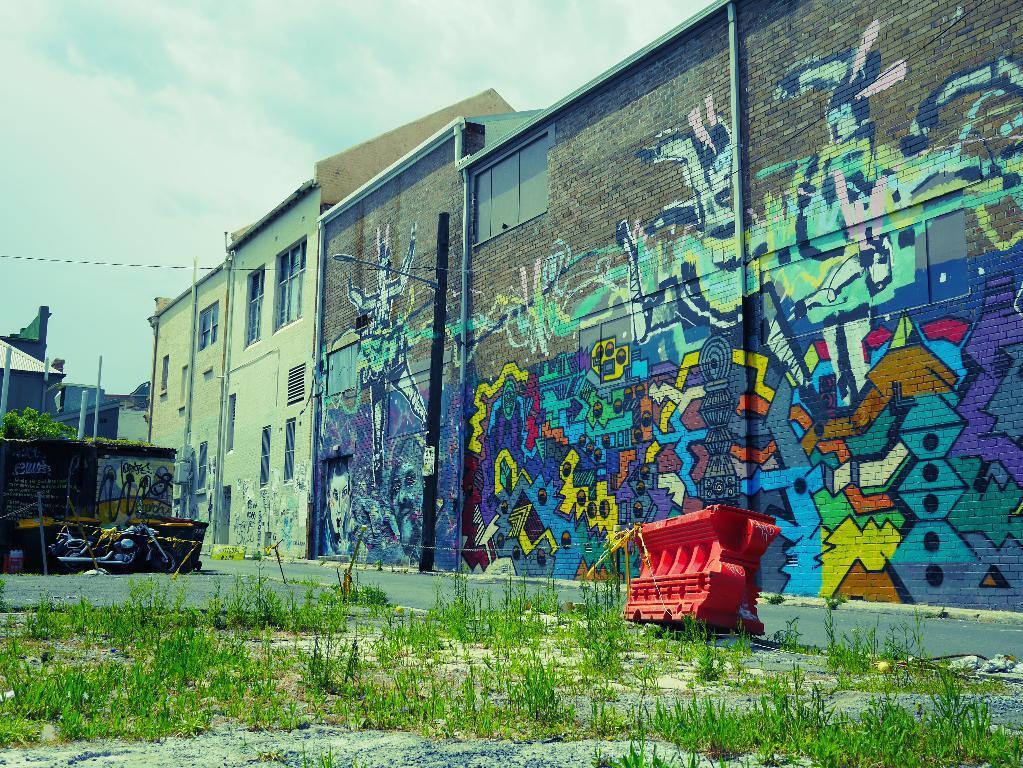Can you describe this image briefly? In this picture we can see the graffiti on the wall, buildings, windows, poles, shed, motorcycle, plants, road, barricades. At the bottom of the image we can see the plants and ground. At the top of the image we can see the clouds in the sky. 